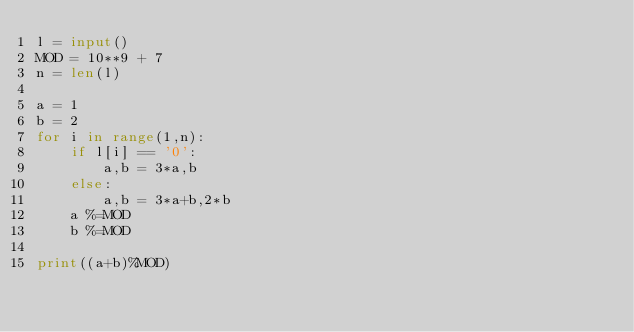Convert code to text. <code><loc_0><loc_0><loc_500><loc_500><_Python_>l = input()
MOD = 10**9 + 7
n = len(l)

a = 1
b = 2
for i in range(1,n):
    if l[i] == '0':
        a,b = 3*a,b
    else:
        a,b = 3*a+b,2*b
    a %=MOD
    b %=MOD

print((a+b)%MOD)</code> 